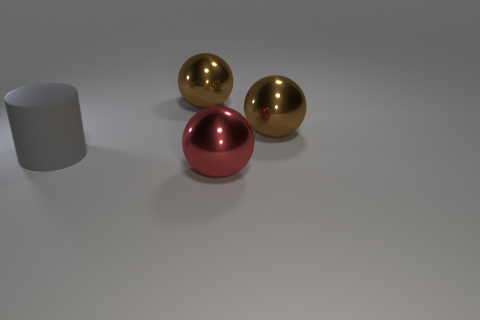There is a brown thing that is left of the object that is in front of the big gray matte thing; what number of gray cylinders are behind it? None. There are no gray cylinders behind the brown object located on the left side of the object in front of the large gray matte surface. The only objects present are two golden spheres and a single red sphere. 